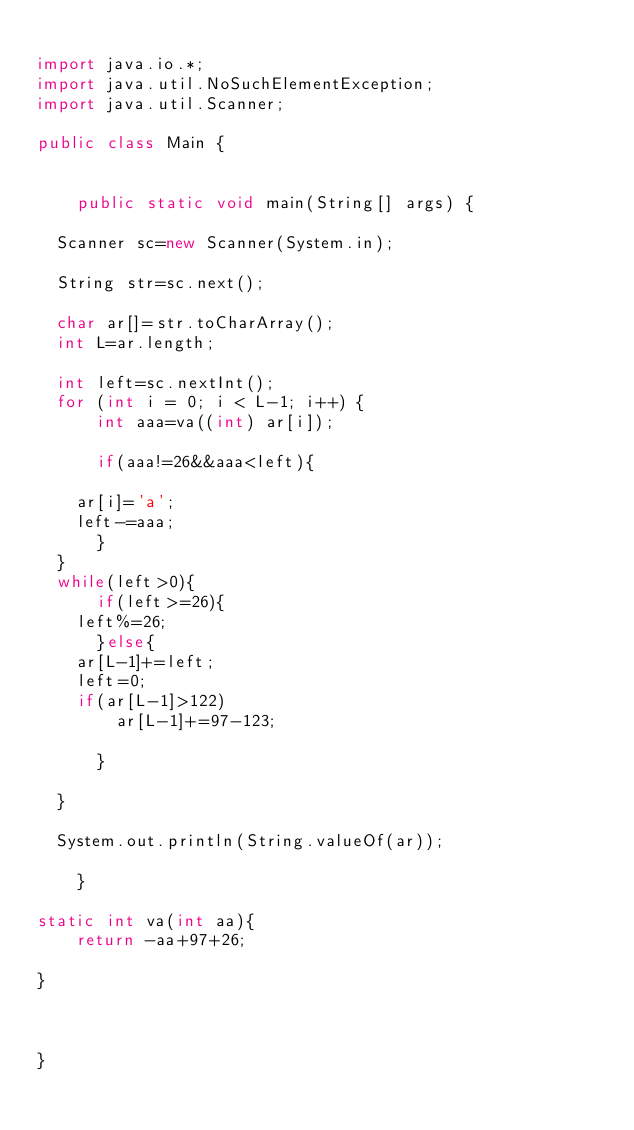<code> <loc_0><loc_0><loc_500><loc_500><_Java_>
import java.io.*;
import java.util.NoSuchElementException;
import java.util.Scanner;

public class Main {


    public static void main(String[] args) {
	
	Scanner sc=new Scanner(System.in);
	
	String str=sc.next();
	
	char ar[]=str.toCharArray();
	int L=ar.length;
	
	int left=sc.nextInt();
	for (int i = 0; i < L-1; i++) {
	    int aaa=va((int) ar[i]);
	    
	    if(aaa!=26&&aaa<left){
		
		ar[i]='a';
		left-=aaa;
	    }
	}
	while(left>0){
	    if(left>=26){
		left%=26;
	    }else{
		ar[L-1]+=left;
		left=0;
		if(ar[L-1]>122)
		    ar[L-1]+=97-123;
		    
	    }
	
	}
	
	System.out.println(String.valueOf(ar));
	
    }

static int va(int aa){
    return -aa+97+26;
        
}
 
    
    
}
</code> 